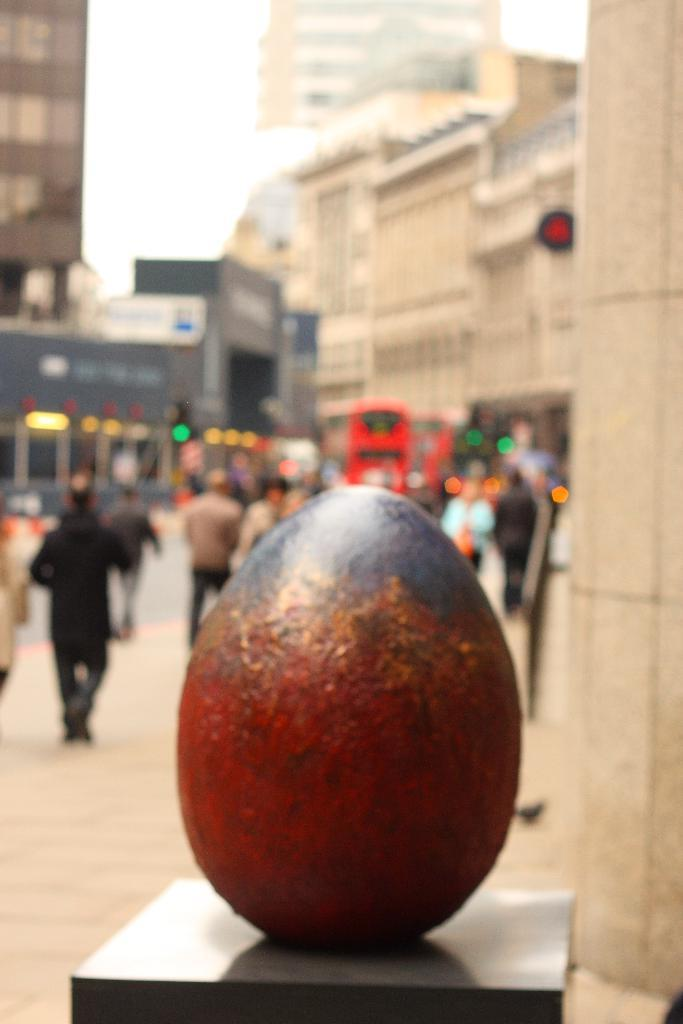What is the shape of the object on the path in the image? The object on the path is oval-shaped. What can be seen behind the object? There are blurred people and a bus visible behind the object. What is in the background of the image? There are buildings, lights, and the sky visible in the background. What type of beast can be seen interacting with the oval-shaped object in the image? There is no beast present in the image; the oval-shaped object is the main subject. How many ducks are visible in the image? There are no ducks present in the image. 